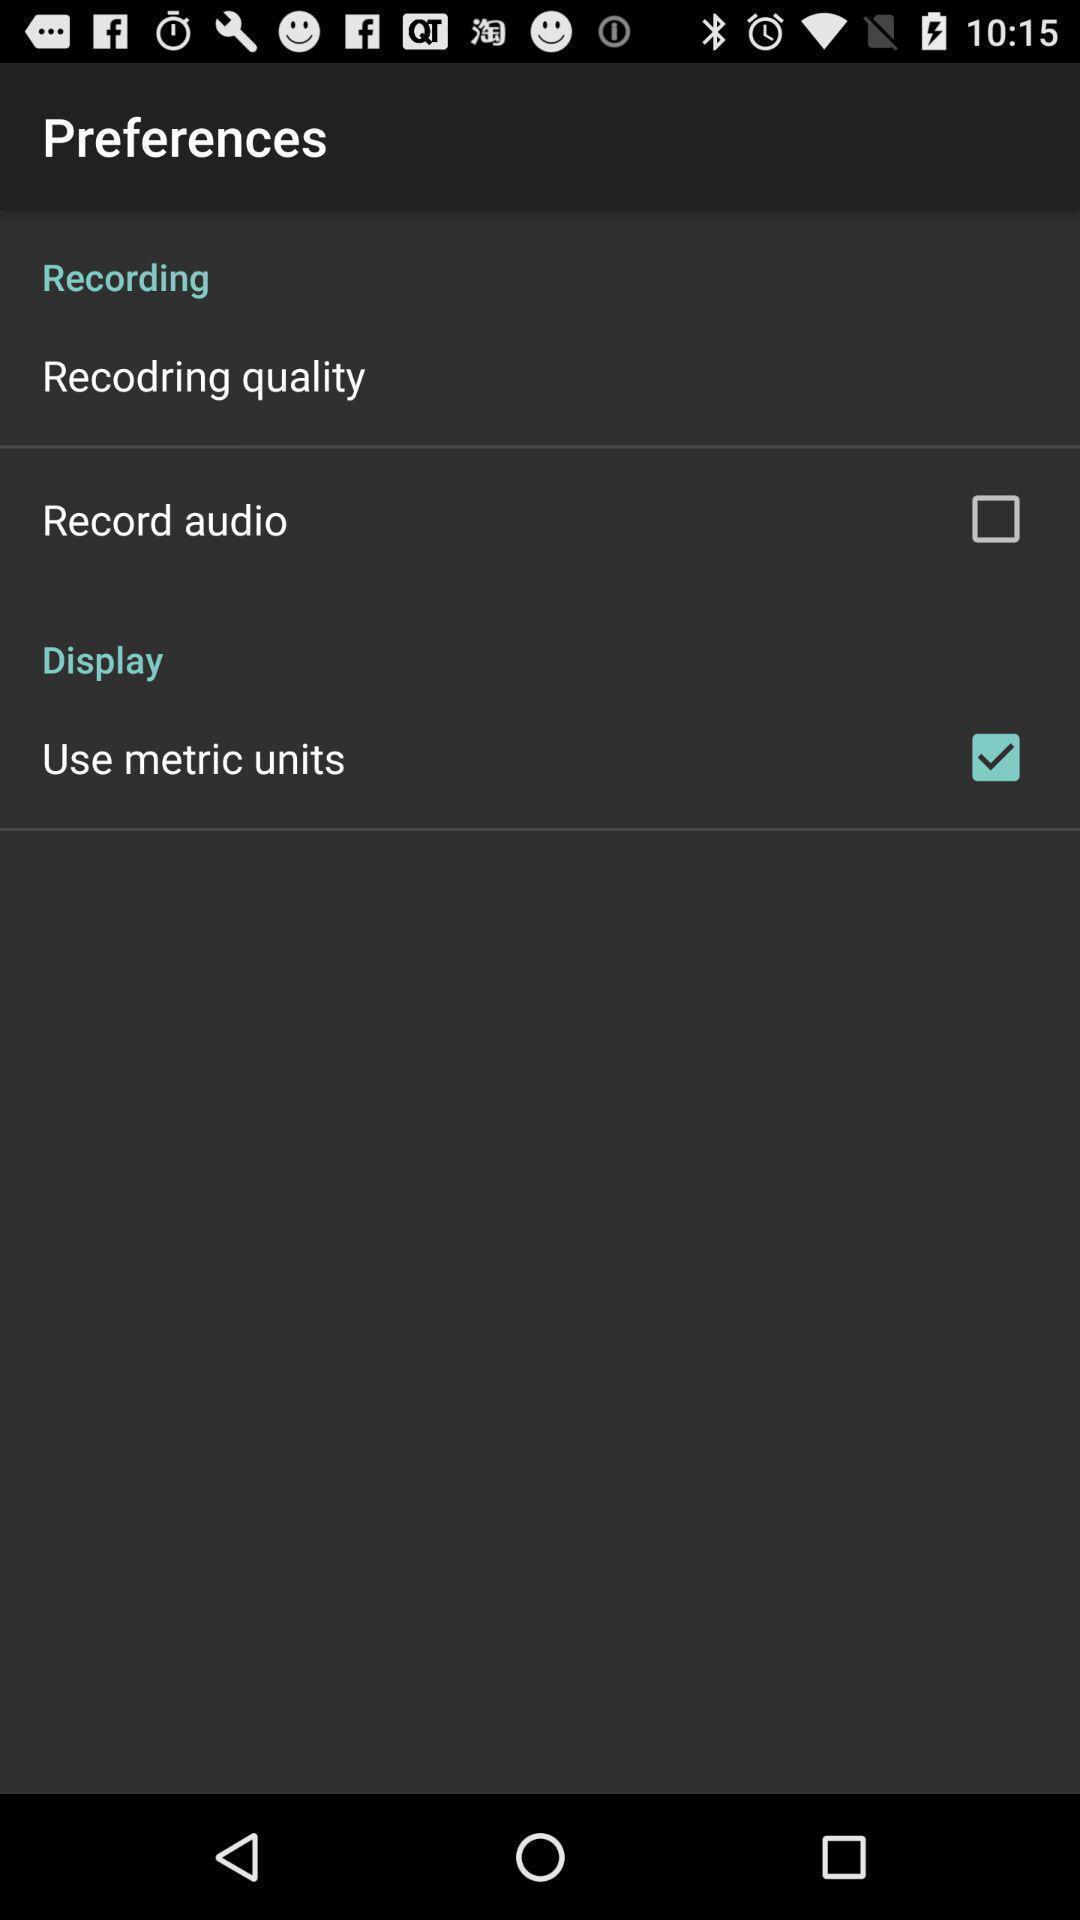Provide a description of this screenshot. Screen shows preferences with options. 